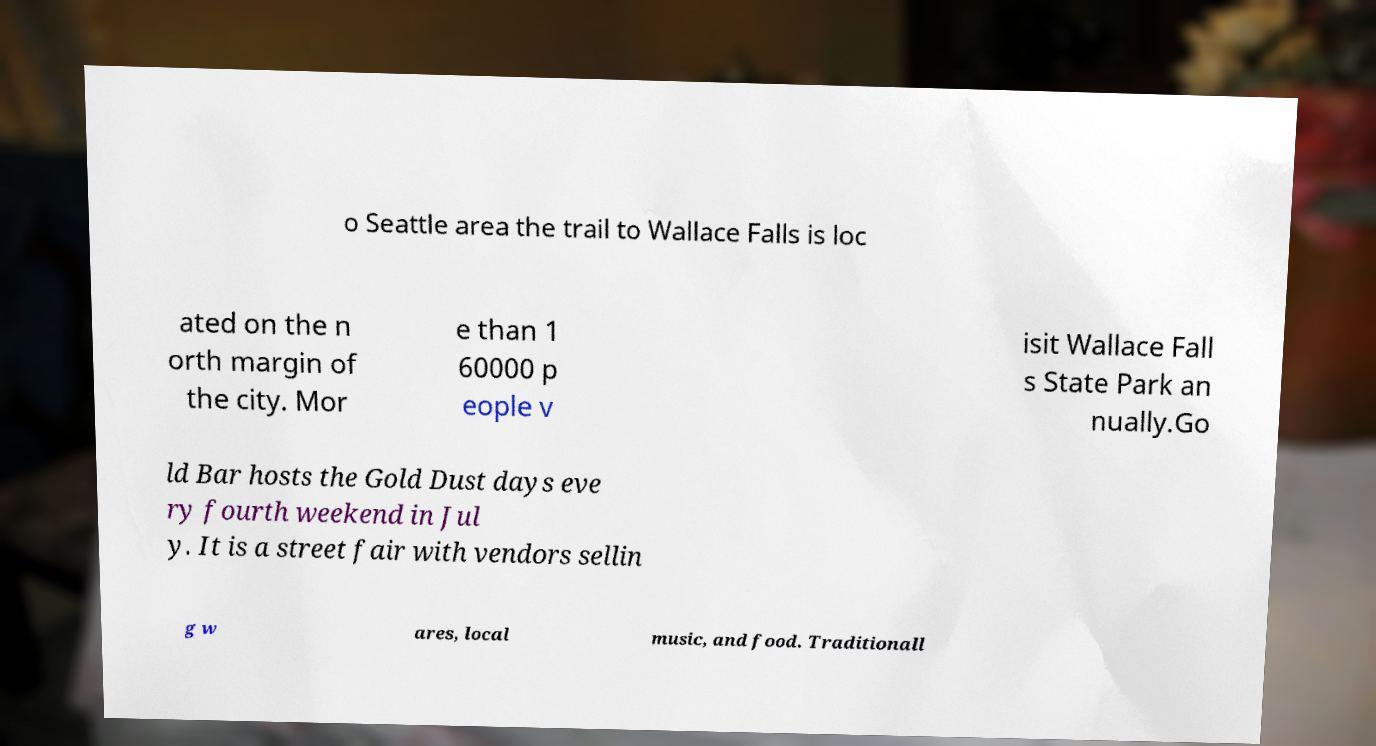There's text embedded in this image that I need extracted. Can you transcribe it verbatim? o Seattle area the trail to Wallace Falls is loc ated on the n orth margin of the city. Mor e than 1 60000 p eople v isit Wallace Fall s State Park an nually.Go ld Bar hosts the Gold Dust days eve ry fourth weekend in Jul y. It is a street fair with vendors sellin g w ares, local music, and food. Traditionall 